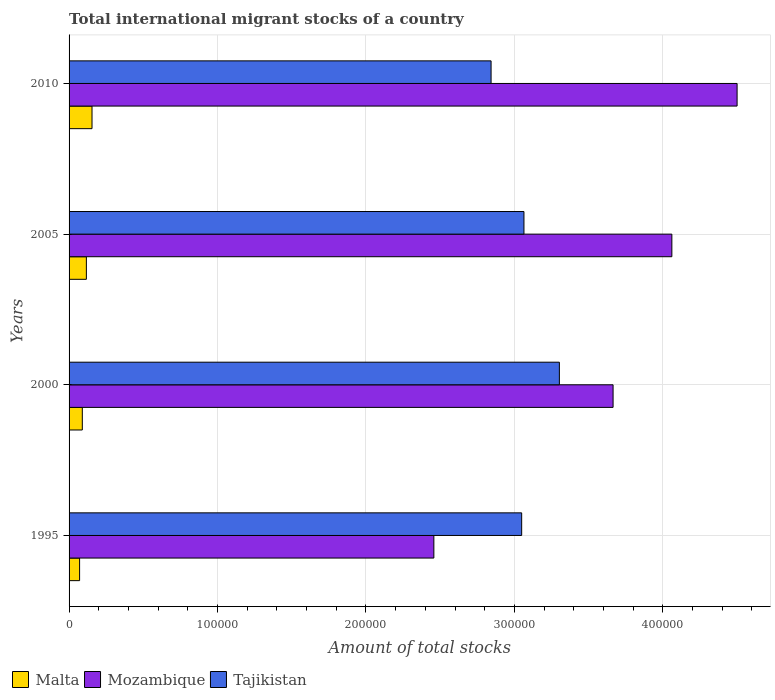Are the number of bars per tick equal to the number of legend labels?
Your answer should be very brief. Yes. Are the number of bars on each tick of the Y-axis equal?
Ensure brevity in your answer.  Yes. How many bars are there on the 4th tick from the top?
Your answer should be compact. 3. In how many cases, is the number of bars for a given year not equal to the number of legend labels?
Provide a succinct answer. 0. What is the amount of total stocks in in Tajikistan in 2000?
Your response must be concise. 3.30e+05. Across all years, what is the maximum amount of total stocks in in Mozambique?
Give a very brief answer. 4.50e+05. Across all years, what is the minimum amount of total stocks in in Malta?
Provide a succinct answer. 7094. In which year was the amount of total stocks in in Malta minimum?
Provide a short and direct response. 1995. What is the total amount of total stocks in in Tajikistan in the graph?
Offer a very short reply. 1.23e+06. What is the difference between the amount of total stocks in in Tajikistan in 1995 and that in 2000?
Keep it short and to the point. -2.54e+04. What is the difference between the amount of total stocks in in Tajikistan in 2010 and the amount of total stocks in in Mozambique in 2005?
Give a very brief answer. -1.22e+05. What is the average amount of total stocks in in Malta per year?
Keep it short and to the point. 1.08e+04. In the year 2005, what is the difference between the amount of total stocks in in Malta and amount of total stocks in in Mozambique?
Provide a short and direct response. -3.94e+05. What is the ratio of the amount of total stocks in in Mozambique in 1995 to that in 2000?
Your response must be concise. 0.67. Is the amount of total stocks in in Malta in 2000 less than that in 2010?
Give a very brief answer. Yes. What is the difference between the highest and the second highest amount of total stocks in in Tajikistan?
Offer a very short reply. 2.39e+04. What is the difference between the highest and the lowest amount of total stocks in in Tajikistan?
Provide a succinct answer. 4.60e+04. In how many years, is the amount of total stocks in in Malta greater than the average amount of total stocks in in Malta taken over all years?
Keep it short and to the point. 2. Is the sum of the amount of total stocks in in Tajikistan in 2005 and 2010 greater than the maximum amount of total stocks in in Malta across all years?
Keep it short and to the point. Yes. What does the 3rd bar from the top in 2010 represents?
Provide a succinct answer. Malta. What does the 2nd bar from the bottom in 2000 represents?
Keep it short and to the point. Mozambique. How many bars are there?
Offer a terse response. 12. Are all the bars in the graph horizontal?
Your answer should be very brief. Yes. What is the difference between two consecutive major ticks on the X-axis?
Your answer should be very brief. 1.00e+05. Does the graph contain grids?
Provide a succinct answer. Yes. Where does the legend appear in the graph?
Give a very brief answer. Bottom left. What is the title of the graph?
Your answer should be compact. Total international migrant stocks of a country. Does "Venezuela" appear as one of the legend labels in the graph?
Give a very brief answer. No. What is the label or title of the X-axis?
Ensure brevity in your answer.  Amount of total stocks. What is the label or title of the Y-axis?
Your answer should be compact. Years. What is the Amount of total stocks of Malta in 1995?
Provide a short and direct response. 7094. What is the Amount of total stocks of Mozambique in 1995?
Provide a succinct answer. 2.46e+05. What is the Amount of total stocks of Tajikistan in 1995?
Offer a very short reply. 3.05e+05. What is the Amount of total stocks in Malta in 2000?
Offer a very short reply. 8922. What is the Amount of total stocks of Mozambique in 2000?
Your answer should be very brief. 3.66e+05. What is the Amount of total stocks of Tajikistan in 2000?
Offer a terse response. 3.30e+05. What is the Amount of total stocks of Malta in 2005?
Offer a terse response. 1.17e+04. What is the Amount of total stocks in Mozambique in 2005?
Offer a terse response. 4.06e+05. What is the Amount of total stocks in Tajikistan in 2005?
Offer a very short reply. 3.06e+05. What is the Amount of total stocks of Malta in 2010?
Ensure brevity in your answer.  1.55e+04. What is the Amount of total stocks in Mozambique in 2010?
Your answer should be compact. 4.50e+05. What is the Amount of total stocks in Tajikistan in 2010?
Ensure brevity in your answer.  2.84e+05. Across all years, what is the maximum Amount of total stocks in Malta?
Your answer should be very brief. 1.55e+04. Across all years, what is the maximum Amount of total stocks in Mozambique?
Provide a short and direct response. 4.50e+05. Across all years, what is the maximum Amount of total stocks of Tajikistan?
Provide a short and direct response. 3.30e+05. Across all years, what is the minimum Amount of total stocks of Malta?
Provide a succinct answer. 7094. Across all years, what is the minimum Amount of total stocks in Mozambique?
Your answer should be compact. 2.46e+05. Across all years, what is the minimum Amount of total stocks in Tajikistan?
Your response must be concise. 2.84e+05. What is the total Amount of total stocks of Malta in the graph?
Your answer should be very brief. 4.31e+04. What is the total Amount of total stocks of Mozambique in the graph?
Give a very brief answer. 1.47e+06. What is the total Amount of total stocks in Tajikistan in the graph?
Make the answer very short. 1.23e+06. What is the difference between the Amount of total stocks in Malta in 1995 and that in 2000?
Provide a succinct answer. -1828. What is the difference between the Amount of total stocks in Mozambique in 1995 and that in 2000?
Your response must be concise. -1.21e+05. What is the difference between the Amount of total stocks in Tajikistan in 1995 and that in 2000?
Your answer should be very brief. -2.54e+04. What is the difference between the Amount of total stocks of Malta in 1995 and that in 2005?
Ensure brevity in your answer.  -4560. What is the difference between the Amount of total stocks in Mozambique in 1995 and that in 2005?
Provide a succinct answer. -1.60e+05. What is the difference between the Amount of total stocks of Tajikistan in 1995 and that in 2005?
Provide a short and direct response. -1533. What is the difference between the Amount of total stocks in Malta in 1995 and that in 2010?
Provide a succinct answer. -8362. What is the difference between the Amount of total stocks of Mozambique in 1995 and that in 2010?
Your response must be concise. -2.04e+05. What is the difference between the Amount of total stocks in Tajikistan in 1995 and that in 2010?
Your response must be concise. 2.06e+04. What is the difference between the Amount of total stocks in Malta in 2000 and that in 2005?
Provide a short and direct response. -2732. What is the difference between the Amount of total stocks of Mozambique in 2000 and that in 2005?
Ensure brevity in your answer.  -3.96e+04. What is the difference between the Amount of total stocks of Tajikistan in 2000 and that in 2005?
Your answer should be very brief. 2.39e+04. What is the difference between the Amount of total stocks in Malta in 2000 and that in 2010?
Your response must be concise. -6534. What is the difference between the Amount of total stocks of Mozambique in 2000 and that in 2010?
Make the answer very short. -8.35e+04. What is the difference between the Amount of total stocks of Tajikistan in 2000 and that in 2010?
Ensure brevity in your answer.  4.60e+04. What is the difference between the Amount of total stocks in Malta in 2005 and that in 2010?
Your response must be concise. -3802. What is the difference between the Amount of total stocks in Mozambique in 2005 and that in 2010?
Your answer should be compact. -4.39e+04. What is the difference between the Amount of total stocks of Tajikistan in 2005 and that in 2010?
Your response must be concise. 2.21e+04. What is the difference between the Amount of total stocks of Malta in 1995 and the Amount of total stocks of Mozambique in 2000?
Keep it short and to the point. -3.59e+05. What is the difference between the Amount of total stocks of Malta in 1995 and the Amount of total stocks of Tajikistan in 2000?
Ensure brevity in your answer.  -3.23e+05. What is the difference between the Amount of total stocks in Mozambique in 1995 and the Amount of total stocks in Tajikistan in 2000?
Offer a terse response. -8.46e+04. What is the difference between the Amount of total stocks in Malta in 1995 and the Amount of total stocks in Mozambique in 2005?
Offer a terse response. -3.99e+05. What is the difference between the Amount of total stocks of Malta in 1995 and the Amount of total stocks of Tajikistan in 2005?
Offer a very short reply. -2.99e+05. What is the difference between the Amount of total stocks in Mozambique in 1995 and the Amount of total stocks in Tajikistan in 2005?
Make the answer very short. -6.07e+04. What is the difference between the Amount of total stocks of Malta in 1995 and the Amount of total stocks of Mozambique in 2010?
Your response must be concise. -4.43e+05. What is the difference between the Amount of total stocks in Malta in 1995 and the Amount of total stocks in Tajikistan in 2010?
Offer a very short reply. -2.77e+05. What is the difference between the Amount of total stocks in Mozambique in 1995 and the Amount of total stocks in Tajikistan in 2010?
Offer a terse response. -3.86e+04. What is the difference between the Amount of total stocks in Malta in 2000 and the Amount of total stocks in Mozambique in 2005?
Your response must be concise. -3.97e+05. What is the difference between the Amount of total stocks of Malta in 2000 and the Amount of total stocks of Tajikistan in 2005?
Give a very brief answer. -2.98e+05. What is the difference between the Amount of total stocks of Mozambique in 2000 and the Amount of total stocks of Tajikistan in 2005?
Provide a succinct answer. 6.00e+04. What is the difference between the Amount of total stocks of Malta in 2000 and the Amount of total stocks of Mozambique in 2010?
Ensure brevity in your answer.  -4.41e+05. What is the difference between the Amount of total stocks in Malta in 2000 and the Amount of total stocks in Tajikistan in 2010?
Offer a terse response. -2.75e+05. What is the difference between the Amount of total stocks in Mozambique in 2000 and the Amount of total stocks in Tajikistan in 2010?
Your answer should be very brief. 8.22e+04. What is the difference between the Amount of total stocks of Malta in 2005 and the Amount of total stocks of Mozambique in 2010?
Your answer should be compact. -4.38e+05. What is the difference between the Amount of total stocks of Malta in 2005 and the Amount of total stocks of Tajikistan in 2010?
Make the answer very short. -2.73e+05. What is the difference between the Amount of total stocks in Mozambique in 2005 and the Amount of total stocks in Tajikistan in 2010?
Give a very brief answer. 1.22e+05. What is the average Amount of total stocks in Malta per year?
Offer a very short reply. 1.08e+04. What is the average Amount of total stocks in Mozambique per year?
Make the answer very short. 3.67e+05. What is the average Amount of total stocks in Tajikistan per year?
Keep it short and to the point. 3.06e+05. In the year 1995, what is the difference between the Amount of total stocks of Malta and Amount of total stocks of Mozambique?
Offer a very short reply. -2.39e+05. In the year 1995, what is the difference between the Amount of total stocks of Malta and Amount of total stocks of Tajikistan?
Make the answer very short. -2.98e+05. In the year 1995, what is the difference between the Amount of total stocks of Mozambique and Amount of total stocks of Tajikistan?
Ensure brevity in your answer.  -5.92e+04. In the year 2000, what is the difference between the Amount of total stocks of Malta and Amount of total stocks of Mozambique?
Give a very brief answer. -3.58e+05. In the year 2000, what is the difference between the Amount of total stocks of Malta and Amount of total stocks of Tajikistan?
Give a very brief answer. -3.21e+05. In the year 2000, what is the difference between the Amount of total stocks in Mozambique and Amount of total stocks in Tajikistan?
Provide a short and direct response. 3.62e+04. In the year 2005, what is the difference between the Amount of total stocks in Malta and Amount of total stocks in Mozambique?
Ensure brevity in your answer.  -3.94e+05. In the year 2005, what is the difference between the Amount of total stocks of Malta and Amount of total stocks of Tajikistan?
Keep it short and to the point. -2.95e+05. In the year 2005, what is the difference between the Amount of total stocks in Mozambique and Amount of total stocks in Tajikistan?
Offer a very short reply. 9.96e+04. In the year 2010, what is the difference between the Amount of total stocks of Malta and Amount of total stocks of Mozambique?
Offer a very short reply. -4.35e+05. In the year 2010, what is the difference between the Amount of total stocks in Malta and Amount of total stocks in Tajikistan?
Your response must be concise. -2.69e+05. In the year 2010, what is the difference between the Amount of total stocks of Mozambique and Amount of total stocks of Tajikistan?
Provide a short and direct response. 1.66e+05. What is the ratio of the Amount of total stocks in Malta in 1995 to that in 2000?
Offer a very short reply. 0.8. What is the ratio of the Amount of total stocks in Mozambique in 1995 to that in 2000?
Give a very brief answer. 0.67. What is the ratio of the Amount of total stocks in Tajikistan in 1995 to that in 2000?
Provide a short and direct response. 0.92. What is the ratio of the Amount of total stocks of Malta in 1995 to that in 2005?
Provide a succinct answer. 0.61. What is the ratio of the Amount of total stocks of Mozambique in 1995 to that in 2005?
Ensure brevity in your answer.  0.61. What is the ratio of the Amount of total stocks of Tajikistan in 1995 to that in 2005?
Offer a terse response. 0.99. What is the ratio of the Amount of total stocks of Malta in 1995 to that in 2010?
Offer a very short reply. 0.46. What is the ratio of the Amount of total stocks in Mozambique in 1995 to that in 2010?
Your answer should be compact. 0.55. What is the ratio of the Amount of total stocks of Tajikistan in 1995 to that in 2010?
Offer a terse response. 1.07. What is the ratio of the Amount of total stocks in Malta in 2000 to that in 2005?
Give a very brief answer. 0.77. What is the ratio of the Amount of total stocks in Mozambique in 2000 to that in 2005?
Keep it short and to the point. 0.9. What is the ratio of the Amount of total stocks of Tajikistan in 2000 to that in 2005?
Ensure brevity in your answer.  1.08. What is the ratio of the Amount of total stocks of Malta in 2000 to that in 2010?
Your answer should be compact. 0.58. What is the ratio of the Amount of total stocks of Mozambique in 2000 to that in 2010?
Provide a succinct answer. 0.81. What is the ratio of the Amount of total stocks of Tajikistan in 2000 to that in 2010?
Offer a very short reply. 1.16. What is the ratio of the Amount of total stocks in Malta in 2005 to that in 2010?
Offer a very short reply. 0.75. What is the ratio of the Amount of total stocks in Mozambique in 2005 to that in 2010?
Give a very brief answer. 0.9. What is the ratio of the Amount of total stocks of Tajikistan in 2005 to that in 2010?
Your answer should be compact. 1.08. What is the difference between the highest and the second highest Amount of total stocks in Malta?
Offer a very short reply. 3802. What is the difference between the highest and the second highest Amount of total stocks in Mozambique?
Make the answer very short. 4.39e+04. What is the difference between the highest and the second highest Amount of total stocks in Tajikistan?
Offer a terse response. 2.39e+04. What is the difference between the highest and the lowest Amount of total stocks in Malta?
Offer a terse response. 8362. What is the difference between the highest and the lowest Amount of total stocks in Mozambique?
Offer a terse response. 2.04e+05. What is the difference between the highest and the lowest Amount of total stocks in Tajikistan?
Offer a terse response. 4.60e+04. 